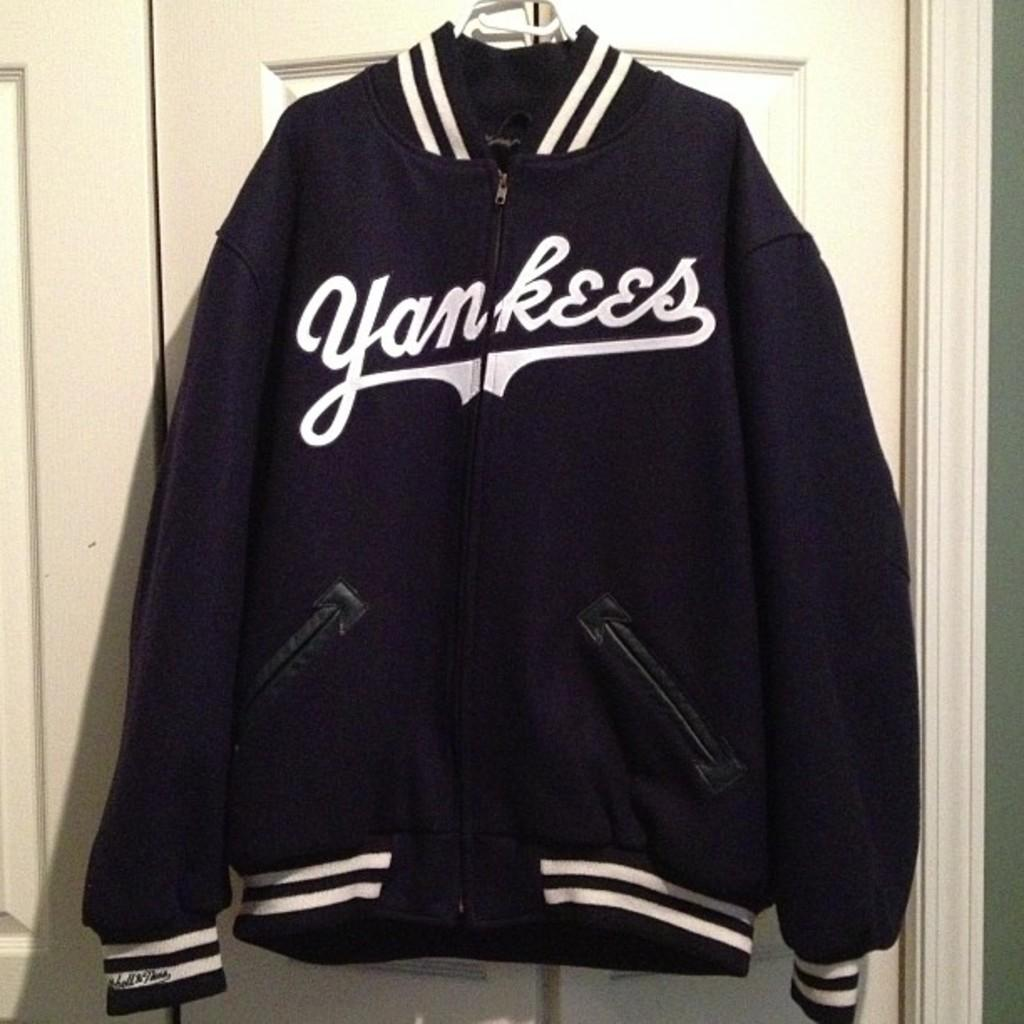<image>
Write a terse but informative summary of the picture. A blue and white Yankees jacket hanging on a door. 